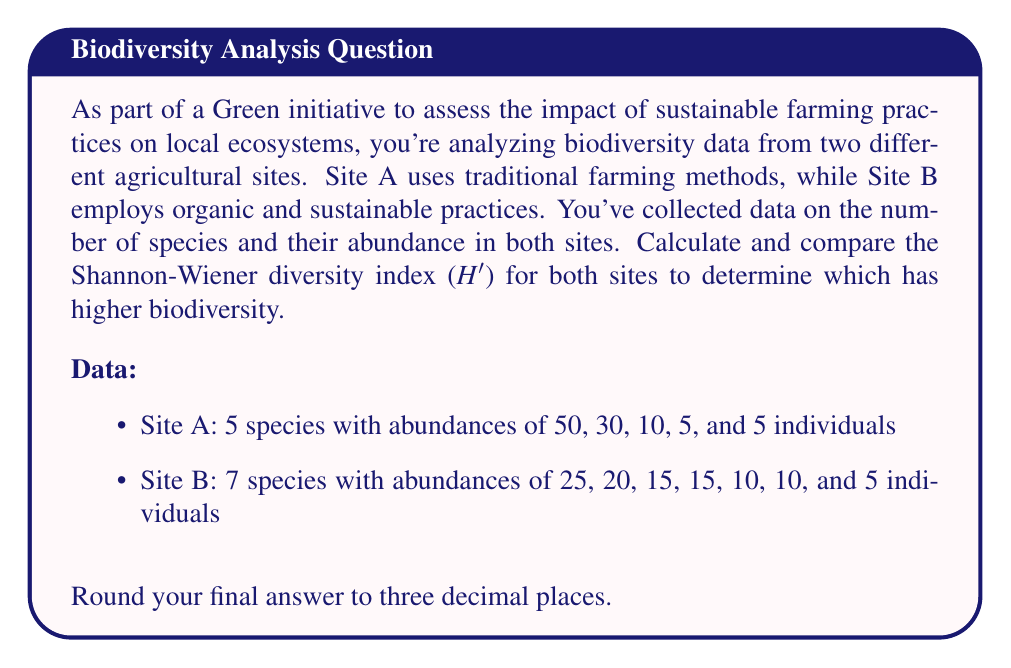What is the answer to this math problem? To calculate the Shannon-Wiener diversity index (H'), we use the formula:

$$H' = -\sum_{i=1}^{R} p_i \ln(p_i)$$

Where:
$R$ is the number of species
$p_i$ is the proportion of individuals belonging to the $i$-th species

Step 1: Calculate the total number of individuals for each site.
Site A: $50 + 30 + 10 + 5 + 5 = 100$
Site B: $25 + 20 + 15 + 15 + 10 + 10 + 5 = 100$

Step 2: Calculate $p_i$ for each species in both sites.

Site A:
$p_1 = 50/100 = 0.5$
$p_2 = 30/100 = 0.3$
$p_3 = 10/100 = 0.1$
$p_4 = 5/100 = 0.05$
$p_5 = 5/100 = 0.05$

Site B:
$p_1 = 25/100 = 0.25$
$p_2 = 20/100 = 0.2$
$p_3 = 15/100 = 0.15$
$p_4 = 15/100 = 0.15$
$p_5 = 10/100 = 0.1$
$p_6 = 10/100 = 0.1$
$p_7 = 5/100 = 0.05$

Step 3: Calculate $H'$ for each site.

Site A:
$$\begin{align*}
H'_A &= -[(0.5 \ln(0.5)) + (0.3 \ln(0.3)) + (0.1 \ln(0.1)) + (0.05 \ln(0.05)) + (0.05 \ln(0.05))] \\
&= -[-0.34657 - 0.36119 - 0.23026 - 0.14979 - 0.14979] \\
&= 1.23760
\end{align*}$$

Site B:
$$\begin{align*}
H'_B &= -[(0.25 \ln(0.25)) + (0.2 \ln(0.2)) + (0.15 \ln(0.15)) + (0.15 \ln(0.15)) + (0.1 \ln(0.1)) + (0.1 \ln(0.1)) + (0.05 \ln(0.05))] \\
&= -[-0.34657 - 0.32189 - 0.28768 - 0.28768 - 0.23026 - 0.23026 - 0.14979] \\
&= 1.85413
\end{align*}$$

Step 4: Compare the results.

The Shannon-Wiener diversity index for Site A is 1.238, while for Site B it is 1.854. A higher value indicates greater biodiversity, so Site B (which uses organic and sustainable practices) has higher biodiversity compared to Site A (which uses traditional farming methods).
Answer: Site A: H' = 1.238
Site B: H' = 1.854

Site B has higher biodiversity. 